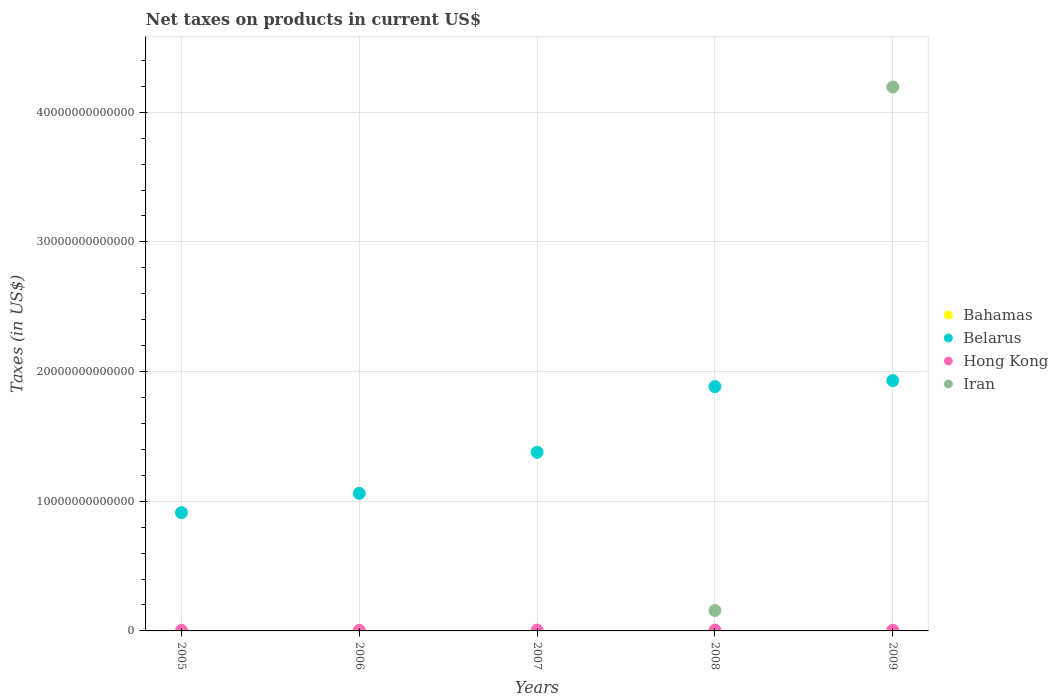How many different coloured dotlines are there?
Provide a short and direct response. 4. Is the number of dotlines equal to the number of legend labels?
Ensure brevity in your answer.  No. Across all years, what is the maximum net taxes on products in Iran?
Provide a short and direct response. 4.19e+13. Across all years, what is the minimum net taxes on products in Belarus?
Provide a short and direct response. 9.12e+12. What is the total net taxes on products in Belarus in the graph?
Your response must be concise. 7.16e+13. What is the difference between the net taxes on products in Belarus in 2006 and that in 2007?
Offer a very short reply. -3.17e+12. What is the difference between the net taxes on products in Belarus in 2005 and the net taxes on products in Iran in 2008?
Provide a short and direct response. 7.54e+12. What is the average net taxes on products in Bahamas per year?
Keep it short and to the point. 6.07e+08. In the year 2009, what is the difference between the net taxes on products in Bahamas and net taxes on products in Hong Kong?
Provide a succinct answer. -5.41e+1. In how many years, is the net taxes on products in Bahamas greater than 12000000000000 US$?
Your answer should be compact. 0. What is the ratio of the net taxes on products in Hong Kong in 2006 to that in 2008?
Give a very brief answer. 0.69. Is the net taxes on products in Hong Kong in 2006 less than that in 2008?
Keep it short and to the point. Yes. What is the difference between the highest and the second highest net taxes on products in Belarus?
Keep it short and to the point. 4.62e+11. What is the difference between the highest and the lowest net taxes on products in Iran?
Offer a terse response. 4.19e+13. Does the net taxes on products in Iran monotonically increase over the years?
Your response must be concise. No. How many years are there in the graph?
Offer a terse response. 5. What is the difference between two consecutive major ticks on the Y-axis?
Provide a short and direct response. 1.00e+13. Are the values on the major ticks of Y-axis written in scientific E-notation?
Your response must be concise. No. Does the graph contain any zero values?
Offer a very short reply. Yes. Where does the legend appear in the graph?
Ensure brevity in your answer.  Center right. How are the legend labels stacked?
Give a very brief answer. Vertical. What is the title of the graph?
Your answer should be compact. Net taxes on products in current US$. What is the label or title of the Y-axis?
Ensure brevity in your answer.  Taxes (in US$). What is the Taxes (in US$) in Bahamas in 2005?
Your answer should be very brief. 5.16e+08. What is the Taxes (in US$) of Belarus in 2005?
Provide a succinct answer. 9.12e+12. What is the Taxes (in US$) in Hong Kong in 2005?
Your answer should be very brief. 3.53e+1. What is the Taxes (in US$) of Iran in 2005?
Provide a succinct answer. 0. What is the Taxes (in US$) of Bahamas in 2006?
Provide a short and direct response. 6.06e+08. What is the Taxes (in US$) of Belarus in 2006?
Your answer should be compact. 1.06e+13. What is the Taxes (in US$) in Hong Kong in 2006?
Provide a short and direct response. 4.03e+1. What is the Taxes (in US$) in Bahamas in 2007?
Your answer should be compact. 6.51e+08. What is the Taxes (in US$) in Belarus in 2007?
Ensure brevity in your answer.  1.38e+13. What is the Taxes (in US$) in Hong Kong in 2007?
Offer a very short reply. 6.46e+1. What is the Taxes (in US$) of Bahamas in 2008?
Ensure brevity in your answer.  6.86e+08. What is the Taxes (in US$) of Belarus in 2008?
Offer a terse response. 1.88e+13. What is the Taxes (in US$) in Hong Kong in 2008?
Make the answer very short. 5.82e+1. What is the Taxes (in US$) of Iran in 2008?
Offer a very short reply. 1.58e+12. What is the Taxes (in US$) of Bahamas in 2009?
Provide a short and direct response. 5.76e+08. What is the Taxes (in US$) in Belarus in 2009?
Offer a terse response. 1.93e+13. What is the Taxes (in US$) of Hong Kong in 2009?
Your answer should be very brief. 5.47e+1. What is the Taxes (in US$) of Iran in 2009?
Your answer should be compact. 4.19e+13. Across all years, what is the maximum Taxes (in US$) in Bahamas?
Offer a very short reply. 6.86e+08. Across all years, what is the maximum Taxes (in US$) in Belarus?
Make the answer very short. 1.93e+13. Across all years, what is the maximum Taxes (in US$) in Hong Kong?
Ensure brevity in your answer.  6.46e+1. Across all years, what is the maximum Taxes (in US$) of Iran?
Your response must be concise. 4.19e+13. Across all years, what is the minimum Taxes (in US$) of Bahamas?
Provide a succinct answer. 5.16e+08. Across all years, what is the minimum Taxes (in US$) in Belarus?
Offer a terse response. 9.12e+12. Across all years, what is the minimum Taxes (in US$) of Hong Kong?
Ensure brevity in your answer.  3.53e+1. Across all years, what is the minimum Taxes (in US$) of Iran?
Your answer should be compact. 0. What is the total Taxes (in US$) of Bahamas in the graph?
Offer a terse response. 3.03e+09. What is the total Taxes (in US$) of Belarus in the graph?
Your answer should be very brief. 7.16e+13. What is the total Taxes (in US$) of Hong Kong in the graph?
Offer a very short reply. 2.53e+11. What is the total Taxes (in US$) of Iran in the graph?
Keep it short and to the point. 4.35e+13. What is the difference between the Taxes (in US$) of Bahamas in 2005 and that in 2006?
Your response must be concise. -9.00e+07. What is the difference between the Taxes (in US$) in Belarus in 2005 and that in 2006?
Your response must be concise. -1.49e+12. What is the difference between the Taxes (in US$) in Hong Kong in 2005 and that in 2006?
Your response must be concise. -5.04e+09. What is the difference between the Taxes (in US$) of Bahamas in 2005 and that in 2007?
Keep it short and to the point. -1.35e+08. What is the difference between the Taxes (in US$) in Belarus in 2005 and that in 2007?
Provide a succinct answer. -4.66e+12. What is the difference between the Taxes (in US$) in Hong Kong in 2005 and that in 2007?
Offer a terse response. -2.93e+1. What is the difference between the Taxes (in US$) in Bahamas in 2005 and that in 2008?
Provide a short and direct response. -1.70e+08. What is the difference between the Taxes (in US$) in Belarus in 2005 and that in 2008?
Offer a terse response. -9.72e+12. What is the difference between the Taxes (in US$) in Hong Kong in 2005 and that in 2008?
Offer a very short reply. -2.29e+1. What is the difference between the Taxes (in US$) in Bahamas in 2005 and that in 2009?
Keep it short and to the point. -6.07e+07. What is the difference between the Taxes (in US$) in Belarus in 2005 and that in 2009?
Provide a succinct answer. -1.02e+13. What is the difference between the Taxes (in US$) of Hong Kong in 2005 and that in 2009?
Give a very brief answer. -1.94e+1. What is the difference between the Taxes (in US$) in Bahamas in 2006 and that in 2007?
Your answer should be very brief. -4.49e+07. What is the difference between the Taxes (in US$) in Belarus in 2006 and that in 2007?
Your answer should be very brief. -3.17e+12. What is the difference between the Taxes (in US$) of Hong Kong in 2006 and that in 2007?
Your answer should be very brief. -2.43e+1. What is the difference between the Taxes (in US$) of Bahamas in 2006 and that in 2008?
Keep it short and to the point. -7.99e+07. What is the difference between the Taxes (in US$) of Belarus in 2006 and that in 2008?
Ensure brevity in your answer.  -8.24e+12. What is the difference between the Taxes (in US$) in Hong Kong in 2006 and that in 2008?
Provide a short and direct response. -1.79e+1. What is the difference between the Taxes (in US$) in Bahamas in 2006 and that in 2009?
Give a very brief answer. 2.93e+07. What is the difference between the Taxes (in US$) of Belarus in 2006 and that in 2009?
Make the answer very short. -8.70e+12. What is the difference between the Taxes (in US$) in Hong Kong in 2006 and that in 2009?
Make the answer very short. -1.43e+1. What is the difference between the Taxes (in US$) of Bahamas in 2007 and that in 2008?
Your response must be concise. -3.50e+07. What is the difference between the Taxes (in US$) of Belarus in 2007 and that in 2008?
Your answer should be compact. -5.07e+12. What is the difference between the Taxes (in US$) of Hong Kong in 2007 and that in 2008?
Your answer should be very brief. 6.40e+09. What is the difference between the Taxes (in US$) of Bahamas in 2007 and that in 2009?
Give a very brief answer. 7.42e+07. What is the difference between the Taxes (in US$) in Belarus in 2007 and that in 2009?
Keep it short and to the point. -5.53e+12. What is the difference between the Taxes (in US$) in Hong Kong in 2007 and that in 2009?
Offer a terse response. 9.94e+09. What is the difference between the Taxes (in US$) of Bahamas in 2008 and that in 2009?
Provide a succinct answer. 1.09e+08. What is the difference between the Taxes (in US$) of Belarus in 2008 and that in 2009?
Provide a succinct answer. -4.62e+11. What is the difference between the Taxes (in US$) of Hong Kong in 2008 and that in 2009?
Make the answer very short. 3.54e+09. What is the difference between the Taxes (in US$) in Iran in 2008 and that in 2009?
Make the answer very short. -4.04e+13. What is the difference between the Taxes (in US$) in Bahamas in 2005 and the Taxes (in US$) in Belarus in 2006?
Offer a terse response. -1.06e+13. What is the difference between the Taxes (in US$) of Bahamas in 2005 and the Taxes (in US$) of Hong Kong in 2006?
Your response must be concise. -3.98e+1. What is the difference between the Taxes (in US$) of Belarus in 2005 and the Taxes (in US$) of Hong Kong in 2006?
Give a very brief answer. 9.08e+12. What is the difference between the Taxes (in US$) of Bahamas in 2005 and the Taxes (in US$) of Belarus in 2007?
Provide a short and direct response. -1.38e+13. What is the difference between the Taxes (in US$) of Bahamas in 2005 and the Taxes (in US$) of Hong Kong in 2007?
Ensure brevity in your answer.  -6.41e+1. What is the difference between the Taxes (in US$) of Belarus in 2005 and the Taxes (in US$) of Hong Kong in 2007?
Your answer should be compact. 9.05e+12. What is the difference between the Taxes (in US$) of Bahamas in 2005 and the Taxes (in US$) of Belarus in 2008?
Give a very brief answer. -1.88e+13. What is the difference between the Taxes (in US$) of Bahamas in 2005 and the Taxes (in US$) of Hong Kong in 2008?
Offer a very short reply. -5.77e+1. What is the difference between the Taxes (in US$) of Bahamas in 2005 and the Taxes (in US$) of Iran in 2008?
Keep it short and to the point. -1.57e+12. What is the difference between the Taxes (in US$) of Belarus in 2005 and the Taxes (in US$) of Hong Kong in 2008?
Provide a succinct answer. 9.06e+12. What is the difference between the Taxes (in US$) of Belarus in 2005 and the Taxes (in US$) of Iran in 2008?
Keep it short and to the point. 7.54e+12. What is the difference between the Taxes (in US$) of Hong Kong in 2005 and the Taxes (in US$) of Iran in 2008?
Give a very brief answer. -1.54e+12. What is the difference between the Taxes (in US$) in Bahamas in 2005 and the Taxes (in US$) in Belarus in 2009?
Offer a terse response. -1.93e+13. What is the difference between the Taxes (in US$) in Bahamas in 2005 and the Taxes (in US$) in Hong Kong in 2009?
Offer a very short reply. -5.42e+1. What is the difference between the Taxes (in US$) in Bahamas in 2005 and the Taxes (in US$) in Iran in 2009?
Offer a terse response. -4.19e+13. What is the difference between the Taxes (in US$) in Belarus in 2005 and the Taxes (in US$) in Hong Kong in 2009?
Ensure brevity in your answer.  9.06e+12. What is the difference between the Taxes (in US$) in Belarus in 2005 and the Taxes (in US$) in Iran in 2009?
Provide a succinct answer. -3.28e+13. What is the difference between the Taxes (in US$) of Hong Kong in 2005 and the Taxes (in US$) of Iran in 2009?
Offer a very short reply. -4.19e+13. What is the difference between the Taxes (in US$) in Bahamas in 2006 and the Taxes (in US$) in Belarus in 2007?
Your answer should be very brief. -1.38e+13. What is the difference between the Taxes (in US$) of Bahamas in 2006 and the Taxes (in US$) of Hong Kong in 2007?
Offer a terse response. -6.40e+1. What is the difference between the Taxes (in US$) of Belarus in 2006 and the Taxes (in US$) of Hong Kong in 2007?
Keep it short and to the point. 1.05e+13. What is the difference between the Taxes (in US$) in Bahamas in 2006 and the Taxes (in US$) in Belarus in 2008?
Make the answer very short. -1.88e+13. What is the difference between the Taxes (in US$) of Bahamas in 2006 and the Taxes (in US$) of Hong Kong in 2008?
Offer a very short reply. -5.76e+1. What is the difference between the Taxes (in US$) of Bahamas in 2006 and the Taxes (in US$) of Iran in 2008?
Give a very brief answer. -1.57e+12. What is the difference between the Taxes (in US$) in Belarus in 2006 and the Taxes (in US$) in Hong Kong in 2008?
Give a very brief answer. 1.05e+13. What is the difference between the Taxes (in US$) of Belarus in 2006 and the Taxes (in US$) of Iran in 2008?
Give a very brief answer. 9.03e+12. What is the difference between the Taxes (in US$) of Hong Kong in 2006 and the Taxes (in US$) of Iran in 2008?
Give a very brief answer. -1.53e+12. What is the difference between the Taxes (in US$) of Bahamas in 2006 and the Taxes (in US$) of Belarus in 2009?
Provide a short and direct response. -1.93e+13. What is the difference between the Taxes (in US$) in Bahamas in 2006 and the Taxes (in US$) in Hong Kong in 2009?
Your answer should be compact. -5.41e+1. What is the difference between the Taxes (in US$) in Bahamas in 2006 and the Taxes (in US$) in Iran in 2009?
Offer a very short reply. -4.19e+13. What is the difference between the Taxes (in US$) in Belarus in 2006 and the Taxes (in US$) in Hong Kong in 2009?
Offer a terse response. 1.06e+13. What is the difference between the Taxes (in US$) of Belarus in 2006 and the Taxes (in US$) of Iran in 2009?
Give a very brief answer. -3.13e+13. What is the difference between the Taxes (in US$) of Hong Kong in 2006 and the Taxes (in US$) of Iran in 2009?
Offer a very short reply. -4.19e+13. What is the difference between the Taxes (in US$) of Bahamas in 2007 and the Taxes (in US$) of Belarus in 2008?
Your answer should be compact. -1.88e+13. What is the difference between the Taxes (in US$) in Bahamas in 2007 and the Taxes (in US$) in Hong Kong in 2008?
Your answer should be compact. -5.76e+1. What is the difference between the Taxes (in US$) of Bahamas in 2007 and the Taxes (in US$) of Iran in 2008?
Make the answer very short. -1.57e+12. What is the difference between the Taxes (in US$) in Belarus in 2007 and the Taxes (in US$) in Hong Kong in 2008?
Provide a short and direct response. 1.37e+13. What is the difference between the Taxes (in US$) of Belarus in 2007 and the Taxes (in US$) of Iran in 2008?
Make the answer very short. 1.22e+13. What is the difference between the Taxes (in US$) of Hong Kong in 2007 and the Taxes (in US$) of Iran in 2008?
Your answer should be compact. -1.51e+12. What is the difference between the Taxes (in US$) of Bahamas in 2007 and the Taxes (in US$) of Belarus in 2009?
Offer a terse response. -1.93e+13. What is the difference between the Taxes (in US$) in Bahamas in 2007 and the Taxes (in US$) in Hong Kong in 2009?
Give a very brief answer. -5.40e+1. What is the difference between the Taxes (in US$) in Bahamas in 2007 and the Taxes (in US$) in Iran in 2009?
Offer a very short reply. -4.19e+13. What is the difference between the Taxes (in US$) of Belarus in 2007 and the Taxes (in US$) of Hong Kong in 2009?
Keep it short and to the point. 1.37e+13. What is the difference between the Taxes (in US$) of Belarus in 2007 and the Taxes (in US$) of Iran in 2009?
Make the answer very short. -2.82e+13. What is the difference between the Taxes (in US$) of Hong Kong in 2007 and the Taxes (in US$) of Iran in 2009?
Your answer should be very brief. -4.19e+13. What is the difference between the Taxes (in US$) of Bahamas in 2008 and the Taxes (in US$) of Belarus in 2009?
Ensure brevity in your answer.  -1.93e+13. What is the difference between the Taxes (in US$) of Bahamas in 2008 and the Taxes (in US$) of Hong Kong in 2009?
Provide a short and direct response. -5.40e+1. What is the difference between the Taxes (in US$) in Bahamas in 2008 and the Taxes (in US$) in Iran in 2009?
Your answer should be compact. -4.19e+13. What is the difference between the Taxes (in US$) of Belarus in 2008 and the Taxes (in US$) of Hong Kong in 2009?
Make the answer very short. 1.88e+13. What is the difference between the Taxes (in US$) in Belarus in 2008 and the Taxes (in US$) in Iran in 2009?
Keep it short and to the point. -2.31e+13. What is the difference between the Taxes (in US$) in Hong Kong in 2008 and the Taxes (in US$) in Iran in 2009?
Give a very brief answer. -4.19e+13. What is the average Taxes (in US$) of Bahamas per year?
Offer a very short reply. 6.07e+08. What is the average Taxes (in US$) of Belarus per year?
Give a very brief answer. 1.43e+13. What is the average Taxes (in US$) in Hong Kong per year?
Give a very brief answer. 5.06e+1. What is the average Taxes (in US$) of Iran per year?
Your answer should be compact. 8.70e+12. In the year 2005, what is the difference between the Taxes (in US$) in Bahamas and Taxes (in US$) in Belarus?
Ensure brevity in your answer.  -9.12e+12. In the year 2005, what is the difference between the Taxes (in US$) in Bahamas and Taxes (in US$) in Hong Kong?
Give a very brief answer. -3.48e+1. In the year 2005, what is the difference between the Taxes (in US$) in Belarus and Taxes (in US$) in Hong Kong?
Offer a very short reply. 9.08e+12. In the year 2006, what is the difference between the Taxes (in US$) in Bahamas and Taxes (in US$) in Belarus?
Your answer should be very brief. -1.06e+13. In the year 2006, what is the difference between the Taxes (in US$) in Bahamas and Taxes (in US$) in Hong Kong?
Ensure brevity in your answer.  -3.97e+1. In the year 2006, what is the difference between the Taxes (in US$) of Belarus and Taxes (in US$) of Hong Kong?
Your answer should be very brief. 1.06e+13. In the year 2007, what is the difference between the Taxes (in US$) of Bahamas and Taxes (in US$) of Belarus?
Offer a very short reply. -1.38e+13. In the year 2007, what is the difference between the Taxes (in US$) of Bahamas and Taxes (in US$) of Hong Kong?
Your response must be concise. -6.40e+1. In the year 2007, what is the difference between the Taxes (in US$) of Belarus and Taxes (in US$) of Hong Kong?
Your answer should be compact. 1.37e+13. In the year 2008, what is the difference between the Taxes (in US$) of Bahamas and Taxes (in US$) of Belarus?
Make the answer very short. -1.88e+13. In the year 2008, what is the difference between the Taxes (in US$) of Bahamas and Taxes (in US$) of Hong Kong?
Your response must be concise. -5.75e+1. In the year 2008, what is the difference between the Taxes (in US$) of Bahamas and Taxes (in US$) of Iran?
Ensure brevity in your answer.  -1.57e+12. In the year 2008, what is the difference between the Taxes (in US$) of Belarus and Taxes (in US$) of Hong Kong?
Give a very brief answer. 1.88e+13. In the year 2008, what is the difference between the Taxes (in US$) of Belarus and Taxes (in US$) of Iran?
Keep it short and to the point. 1.73e+13. In the year 2008, what is the difference between the Taxes (in US$) of Hong Kong and Taxes (in US$) of Iran?
Your response must be concise. -1.52e+12. In the year 2009, what is the difference between the Taxes (in US$) in Bahamas and Taxes (in US$) in Belarus?
Make the answer very short. -1.93e+13. In the year 2009, what is the difference between the Taxes (in US$) in Bahamas and Taxes (in US$) in Hong Kong?
Provide a short and direct response. -5.41e+1. In the year 2009, what is the difference between the Taxes (in US$) in Bahamas and Taxes (in US$) in Iran?
Offer a terse response. -4.19e+13. In the year 2009, what is the difference between the Taxes (in US$) in Belarus and Taxes (in US$) in Hong Kong?
Your response must be concise. 1.92e+13. In the year 2009, what is the difference between the Taxes (in US$) of Belarus and Taxes (in US$) of Iran?
Ensure brevity in your answer.  -2.26e+13. In the year 2009, what is the difference between the Taxes (in US$) of Hong Kong and Taxes (in US$) of Iran?
Offer a terse response. -4.19e+13. What is the ratio of the Taxes (in US$) of Bahamas in 2005 to that in 2006?
Offer a terse response. 0.85. What is the ratio of the Taxes (in US$) in Belarus in 2005 to that in 2006?
Provide a short and direct response. 0.86. What is the ratio of the Taxes (in US$) of Hong Kong in 2005 to that in 2006?
Offer a very short reply. 0.88. What is the ratio of the Taxes (in US$) of Bahamas in 2005 to that in 2007?
Offer a terse response. 0.79. What is the ratio of the Taxes (in US$) in Belarus in 2005 to that in 2007?
Provide a short and direct response. 0.66. What is the ratio of the Taxes (in US$) in Hong Kong in 2005 to that in 2007?
Give a very brief answer. 0.55. What is the ratio of the Taxes (in US$) in Bahamas in 2005 to that in 2008?
Give a very brief answer. 0.75. What is the ratio of the Taxes (in US$) in Belarus in 2005 to that in 2008?
Offer a terse response. 0.48. What is the ratio of the Taxes (in US$) in Hong Kong in 2005 to that in 2008?
Make the answer very short. 0.61. What is the ratio of the Taxes (in US$) of Bahamas in 2005 to that in 2009?
Make the answer very short. 0.89. What is the ratio of the Taxes (in US$) of Belarus in 2005 to that in 2009?
Your answer should be compact. 0.47. What is the ratio of the Taxes (in US$) of Hong Kong in 2005 to that in 2009?
Provide a short and direct response. 0.65. What is the ratio of the Taxes (in US$) of Bahamas in 2006 to that in 2007?
Give a very brief answer. 0.93. What is the ratio of the Taxes (in US$) in Belarus in 2006 to that in 2007?
Make the answer very short. 0.77. What is the ratio of the Taxes (in US$) in Hong Kong in 2006 to that in 2007?
Keep it short and to the point. 0.62. What is the ratio of the Taxes (in US$) of Bahamas in 2006 to that in 2008?
Offer a terse response. 0.88. What is the ratio of the Taxes (in US$) in Belarus in 2006 to that in 2008?
Give a very brief answer. 0.56. What is the ratio of the Taxes (in US$) of Hong Kong in 2006 to that in 2008?
Keep it short and to the point. 0.69. What is the ratio of the Taxes (in US$) of Bahamas in 2006 to that in 2009?
Your answer should be very brief. 1.05. What is the ratio of the Taxes (in US$) of Belarus in 2006 to that in 2009?
Provide a short and direct response. 0.55. What is the ratio of the Taxes (in US$) in Hong Kong in 2006 to that in 2009?
Your response must be concise. 0.74. What is the ratio of the Taxes (in US$) in Bahamas in 2007 to that in 2008?
Make the answer very short. 0.95. What is the ratio of the Taxes (in US$) of Belarus in 2007 to that in 2008?
Your response must be concise. 0.73. What is the ratio of the Taxes (in US$) in Hong Kong in 2007 to that in 2008?
Provide a succinct answer. 1.11. What is the ratio of the Taxes (in US$) of Bahamas in 2007 to that in 2009?
Make the answer very short. 1.13. What is the ratio of the Taxes (in US$) of Belarus in 2007 to that in 2009?
Make the answer very short. 0.71. What is the ratio of the Taxes (in US$) of Hong Kong in 2007 to that in 2009?
Provide a succinct answer. 1.18. What is the ratio of the Taxes (in US$) of Bahamas in 2008 to that in 2009?
Make the answer very short. 1.19. What is the ratio of the Taxes (in US$) of Belarus in 2008 to that in 2009?
Your answer should be compact. 0.98. What is the ratio of the Taxes (in US$) in Hong Kong in 2008 to that in 2009?
Ensure brevity in your answer.  1.06. What is the ratio of the Taxes (in US$) in Iran in 2008 to that in 2009?
Provide a short and direct response. 0.04. What is the difference between the highest and the second highest Taxes (in US$) in Bahamas?
Offer a terse response. 3.50e+07. What is the difference between the highest and the second highest Taxes (in US$) in Belarus?
Provide a short and direct response. 4.62e+11. What is the difference between the highest and the second highest Taxes (in US$) of Hong Kong?
Offer a terse response. 6.40e+09. What is the difference between the highest and the lowest Taxes (in US$) of Bahamas?
Provide a succinct answer. 1.70e+08. What is the difference between the highest and the lowest Taxes (in US$) of Belarus?
Ensure brevity in your answer.  1.02e+13. What is the difference between the highest and the lowest Taxes (in US$) of Hong Kong?
Ensure brevity in your answer.  2.93e+1. What is the difference between the highest and the lowest Taxes (in US$) in Iran?
Give a very brief answer. 4.19e+13. 